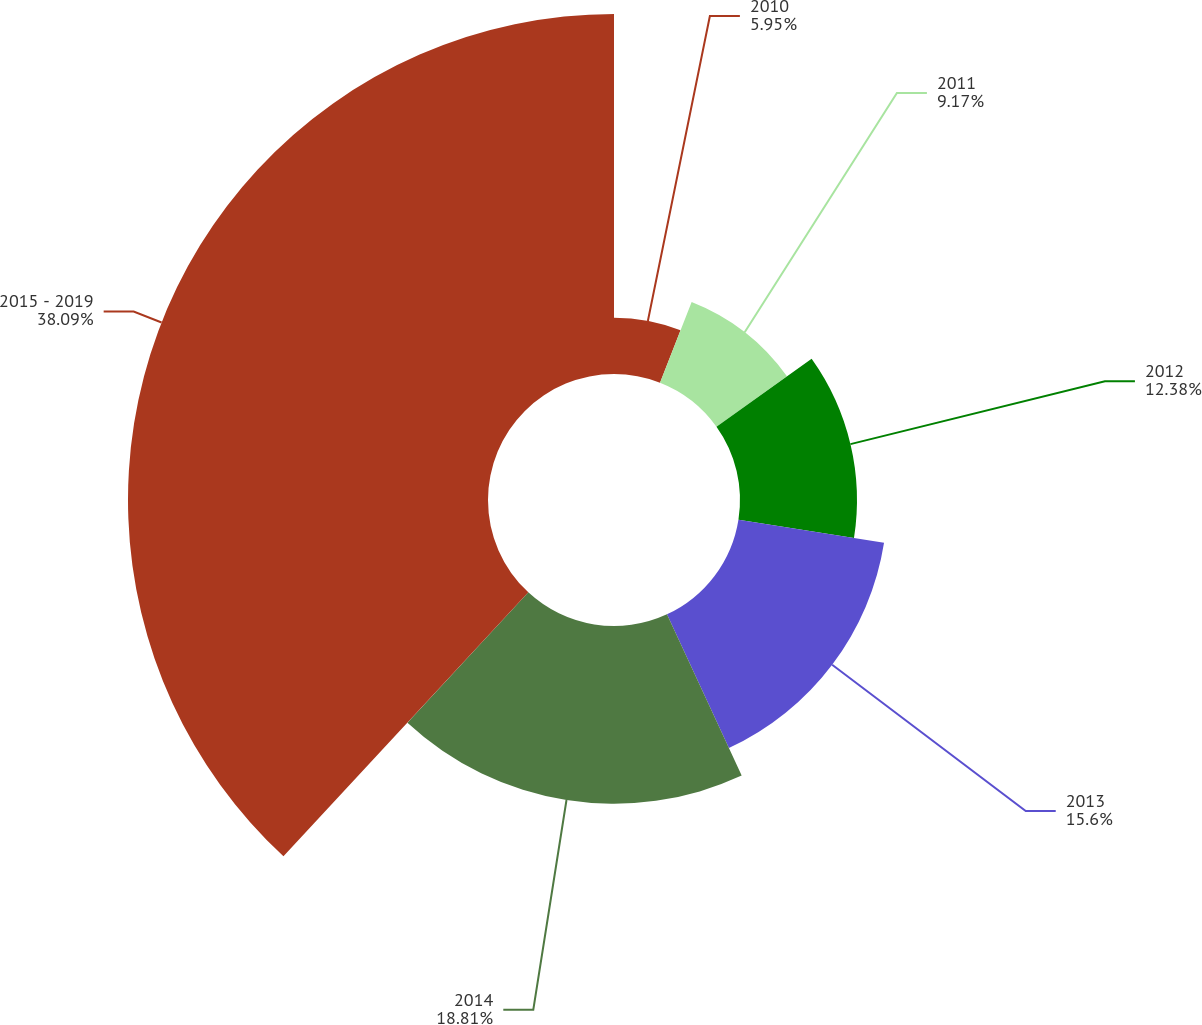Convert chart to OTSL. <chart><loc_0><loc_0><loc_500><loc_500><pie_chart><fcel>2010<fcel>2011<fcel>2012<fcel>2013<fcel>2014<fcel>2015 - 2019<nl><fcel>5.95%<fcel>9.17%<fcel>12.38%<fcel>15.6%<fcel>18.81%<fcel>38.1%<nl></chart> 